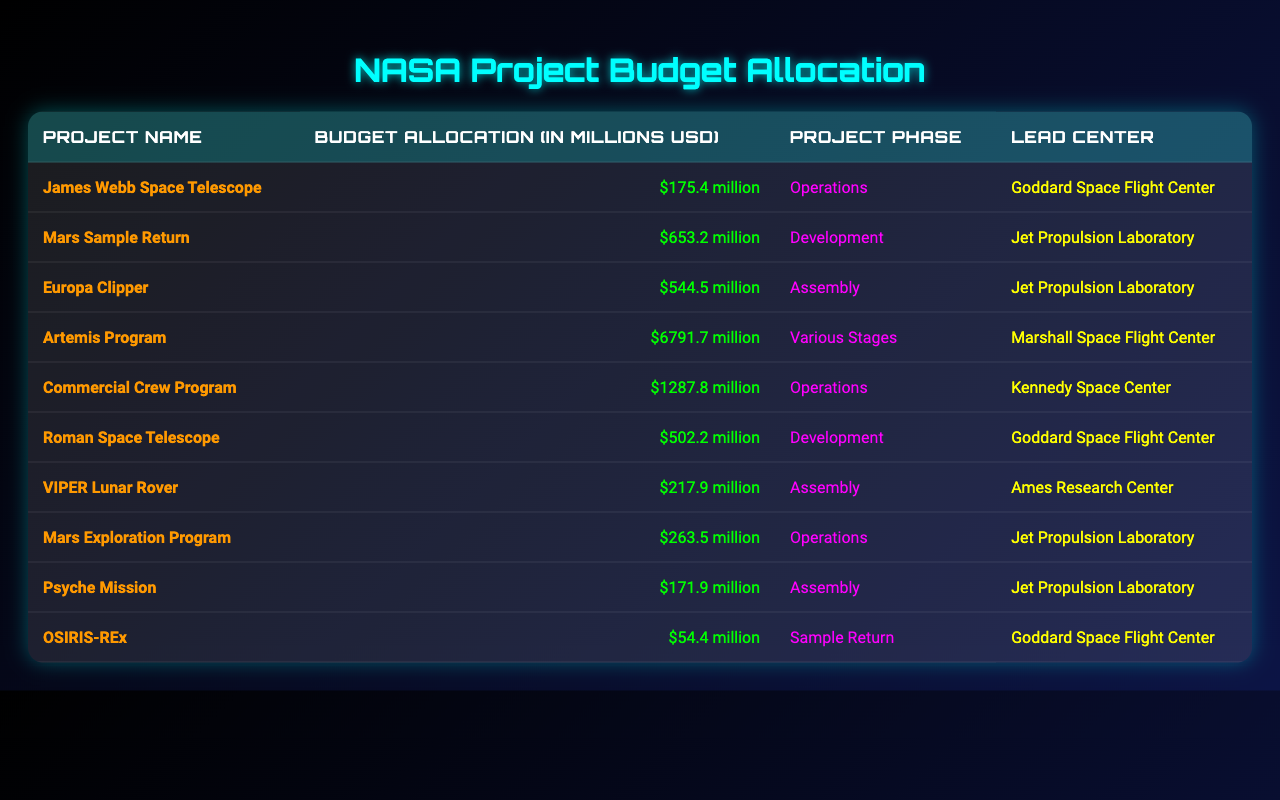What is the total budget allocation for all projects listed? To find the total budget allocation, I need to sum the budget allocations of all projects: (175.4 + 653.2 + 544.5 + 6791.7 + 1287.8 + 502.2 + 217.9 + 263.5 + 171.9 + 54.4) = 10087.1 million USD.
Answer: 10087.1 million USD Which project has the highest budget allocation? I will look for the maximum budget allocation among the projects. The Artemis Program has the largest allocation at 6791.7 million USD.
Answer: Artemis Program How many projects are currently in the "Development" phase? I will count the projects in the "Development" phase from the table, which are Mars Sample Return and Roman Space Telescope (2 projects).
Answer: 2 What is the budget allocation for the Mars Exploration Program? The budget allocation for the Mars Exploration Program is clearly listed in the table, which is 263.5 million USD.
Answer: 263.5 million USD Is the OSIRIS-REx project in the "Assembly" phase? I will check the phase listed for the OSIRIS-REx project, and it is stated to be in the "Sample Return" phase, not "Assembly."
Answer: No What is the average budget allocation for projects led by the Jet Propulsion Laboratory? The projects led by the Jet Propulsion Laboratory are Mars Sample Return, Europa Clipper, Mars Exploration Program, and Psyche Mission. Their budget allocations are (653.2 + 544.5 + 263.5 + 171.9) = 1633.1 million USD. There are 4 projects, so the average is 1633.1/4 = 408.275 million USD.
Answer: 408.275 million USD Which project has the lowest budget allocation, and what is its budget? I will check the budget allocations in the table. The OSIRIS-REx project has the lowest budget at 54.4 million USD.
Answer: OSIRIS-REx, 54.4 million USD How much more budget is allocated to the Artemis Program compared to the Commercial Crew Program? I will subtract the budget of the Commercial Crew Program (1287.8 million USD) from the Artemis Program (6791.7 million USD). The difference is 6791.7 - 1287.8 = 5503.9 million USD.
Answer: 5503.9 million USD What percentage of the total budget is allocated to the Commercial Crew Program? First, I calculate the percentage by: (1287.8 / 10087.1) * 100 = 12.75%.
Answer: 12.75% Are the total allocations for projects in the "Operations" phase greater than those in the "Development" phase? The total for the "Operations" phase is (175.4 + 1287.8 + 263.5) = 1726.7 million USD. The total for the "Development" phase is (653.2 + 502.2) = 1155.4 million USD. Since 1726.7 > 1155.4, the statement is true.
Answer: Yes 